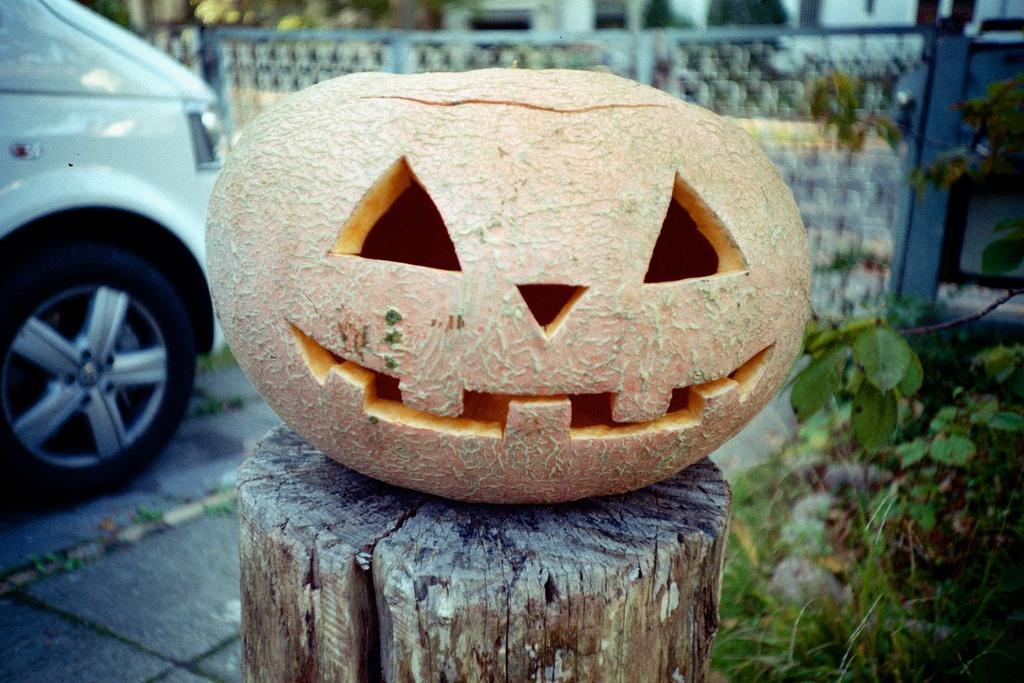Describe this image in one or two sentences. In this image I can see a pumpkin which is sliced into the shape of a person's head on a wooden log. In the background I can see a white colored car on the ground, few trees and the wall. 